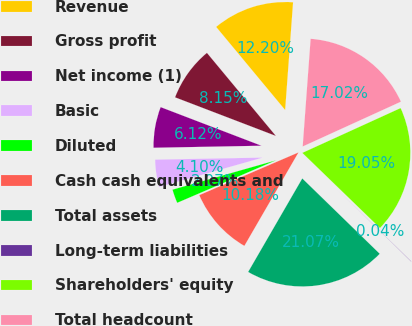<chart> <loc_0><loc_0><loc_500><loc_500><pie_chart><fcel>Revenue<fcel>Gross profit<fcel>Net income (1)<fcel>Basic<fcel>Diluted<fcel>Cash cash equivalents and<fcel>Total assets<fcel>Long-term liabilities<fcel>Shareholders' equity<fcel>Total headcount<nl><fcel>12.2%<fcel>8.15%<fcel>6.12%<fcel>4.1%<fcel>2.07%<fcel>10.18%<fcel>21.07%<fcel>0.04%<fcel>19.05%<fcel>17.02%<nl></chart> 